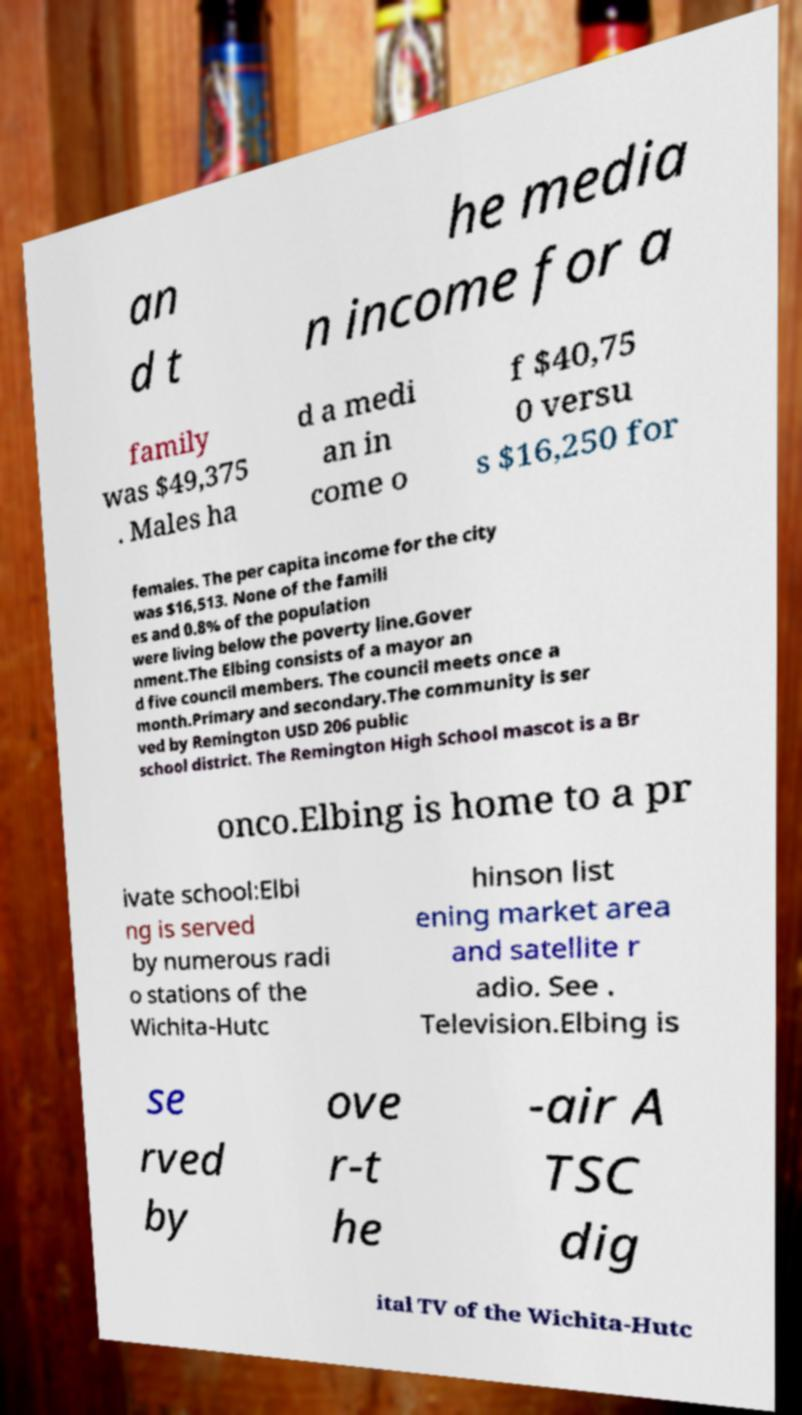What messages or text are displayed in this image? I need them in a readable, typed format. an d t he media n income for a family was $49,375 . Males ha d a medi an in come o f $40,75 0 versu s $16,250 for females. The per capita income for the city was $16,513. None of the famili es and 0.8% of the population were living below the poverty line.Gover nment.The Elbing consists of a mayor an d five council members. The council meets once a month.Primary and secondary.The community is ser ved by Remington USD 206 public school district. The Remington High School mascot is a Br onco.Elbing is home to a pr ivate school:Elbi ng is served by numerous radi o stations of the Wichita-Hutc hinson list ening market area and satellite r adio. See . Television.Elbing is se rved by ove r-t he -air A TSC dig ital TV of the Wichita-Hutc 